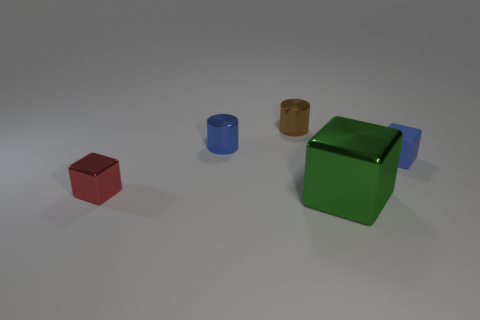Subtract 1 cubes. How many cubes are left? 2 Subtract all metallic cubes. How many cubes are left? 1 Add 1 big gray cylinders. How many objects exist? 6 Subtract all cylinders. How many objects are left? 3 Add 5 things. How many things are left? 10 Add 1 tiny red metal objects. How many tiny red metal objects exist? 2 Subtract 0 yellow cubes. How many objects are left? 5 Subtract all blue rubber objects. Subtract all blue rubber cubes. How many objects are left? 3 